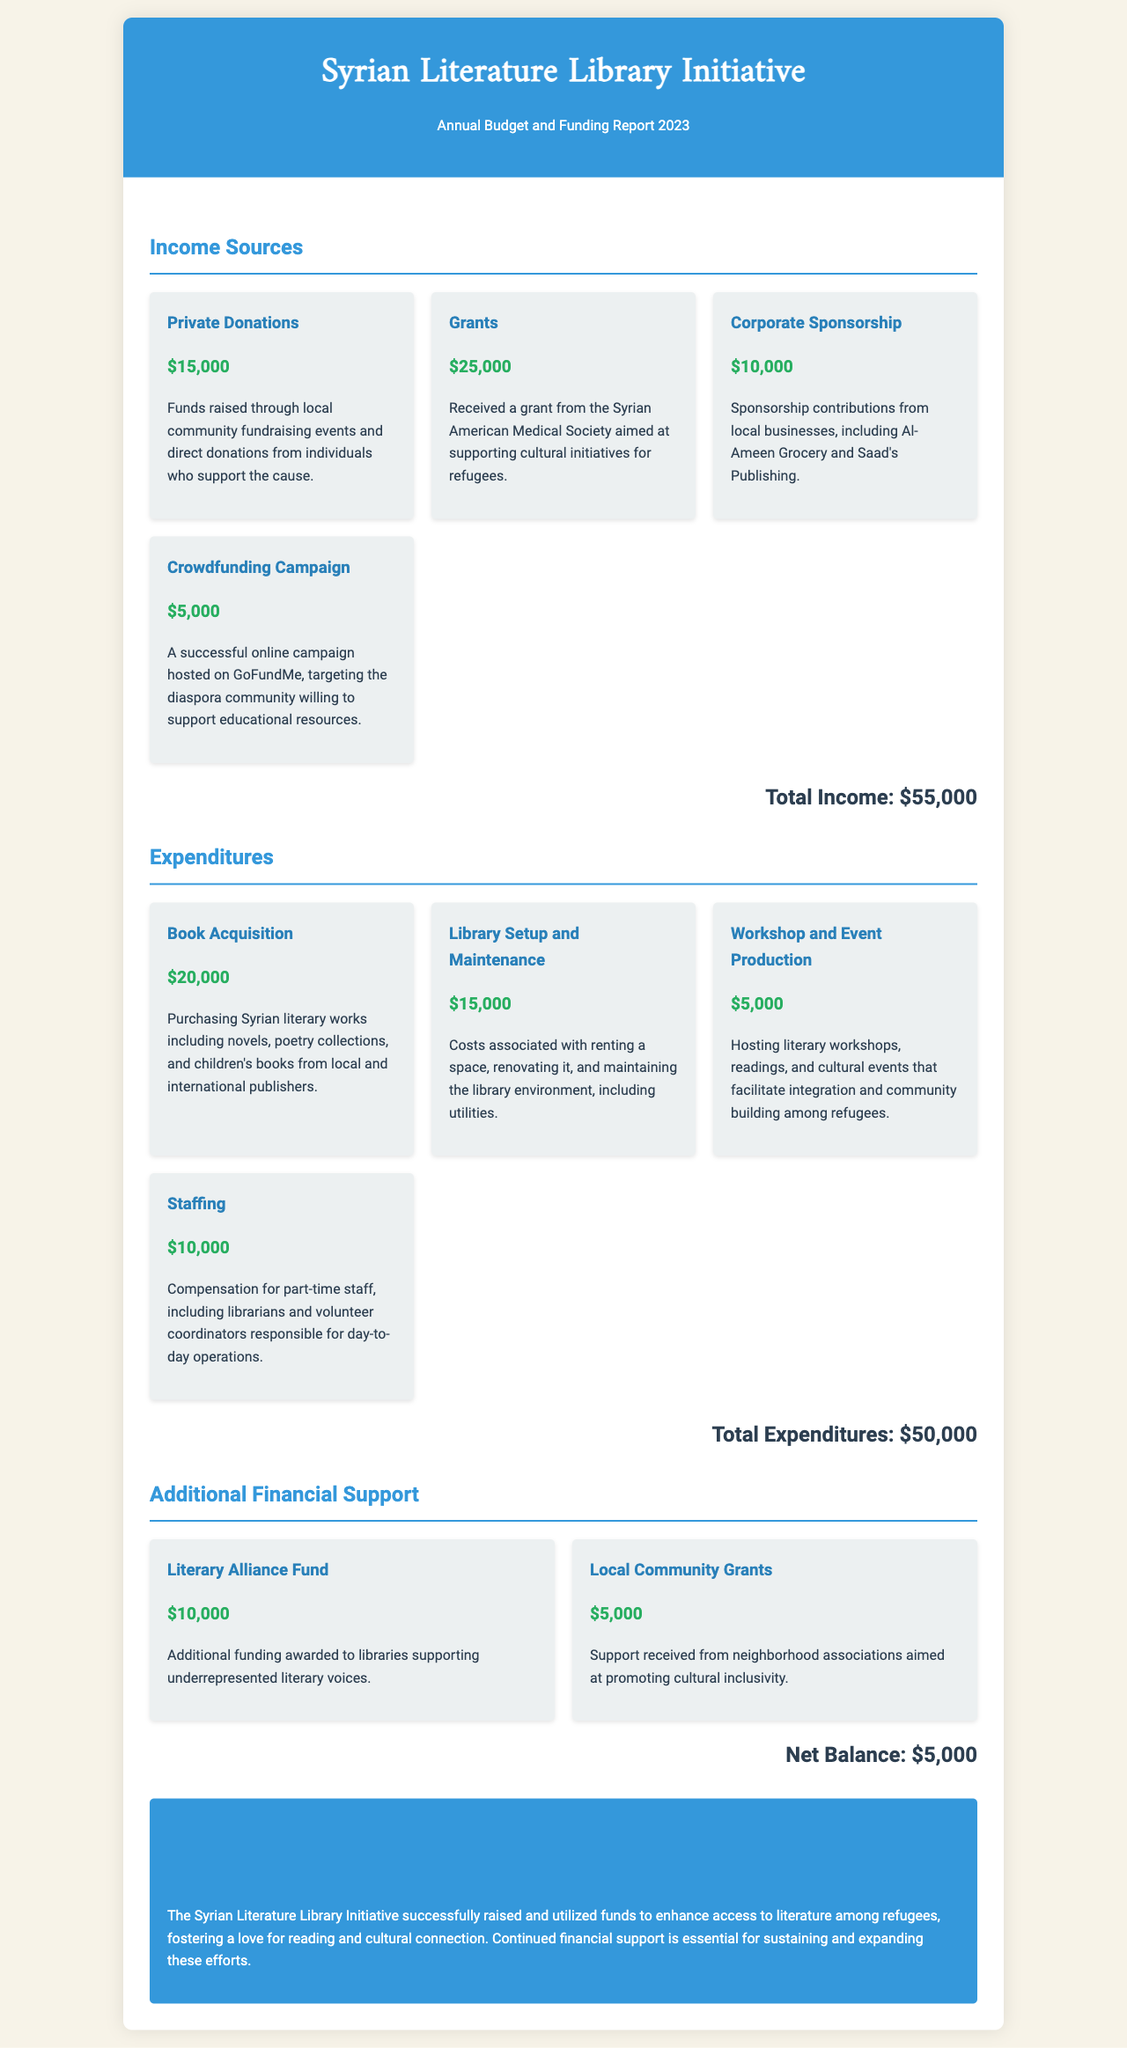What is the total income? The total income is the sum of all income sources listed in the document, which are $15,000 + $25,000 + $10,000 + $5,000.
Answer: $55,000 What was the expenditure on book acquisition? The expenditure on book acquisition is specifically detailed in the document as $20,000.
Answer: $20,000 Which organization provided a grant for the initiative? The document states that the grant was received from the Syrian American Medical Society.
Answer: Syrian American Medical Society What is the net balance? The net balance is calculated by subtracting total expenditures from total income, which is $55,000 - $50,000.
Answer: $5,000 How much funding was received from local community grants? The document mentions that support from local community grants amounted to $5,000.
Answer: $5,000 What is one of the purposes of the funds raised? According to the document, one of the purposes is to enhance access to literature among refugees.
Answer: Enhance access to literature What was the total amount spent on staffing? The total expenditure on staffing is specifically listed as $10,000 in the expenditures section.
Answer: $10,000 What was the amount received from the Literary Alliance Fund? The document notes that $10,000 was awarded from the Literary Alliance Fund for the initiative.
Answer: $10,000 What type of events does the initiative host? The document indicates that the initiative hosts literary workshops, readings, and cultural events.
Answer: Literary workshops, readings, cultural events 